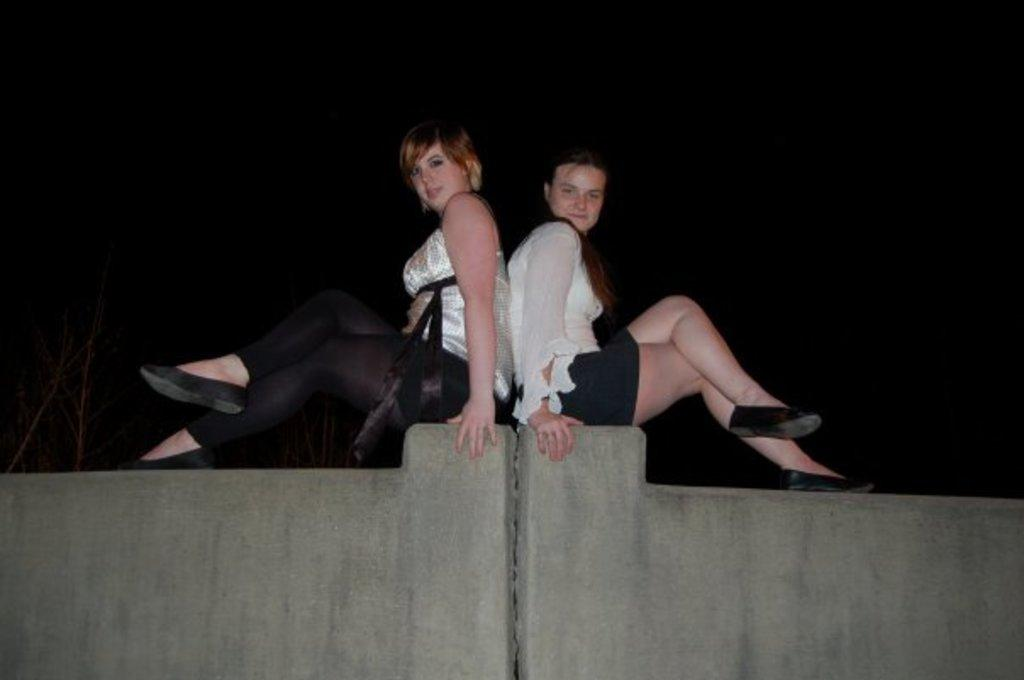How many walls are visible in the image? There are two walls in the image. What are the ladies doing on the walls? Two ladies are sitting on the walls. What can be seen in the background of the image? There are trees in the background of the image. How would you describe the lighting in the image? The background of the image appears to be dark. What type of throat medicine is the man taking in the image? There is no man present in the image, and therefore no throat medicine can be observed. What is being served for dinner in the image? There is no dinner being served in the image; it features two ladies sitting on walls with trees in the background. 